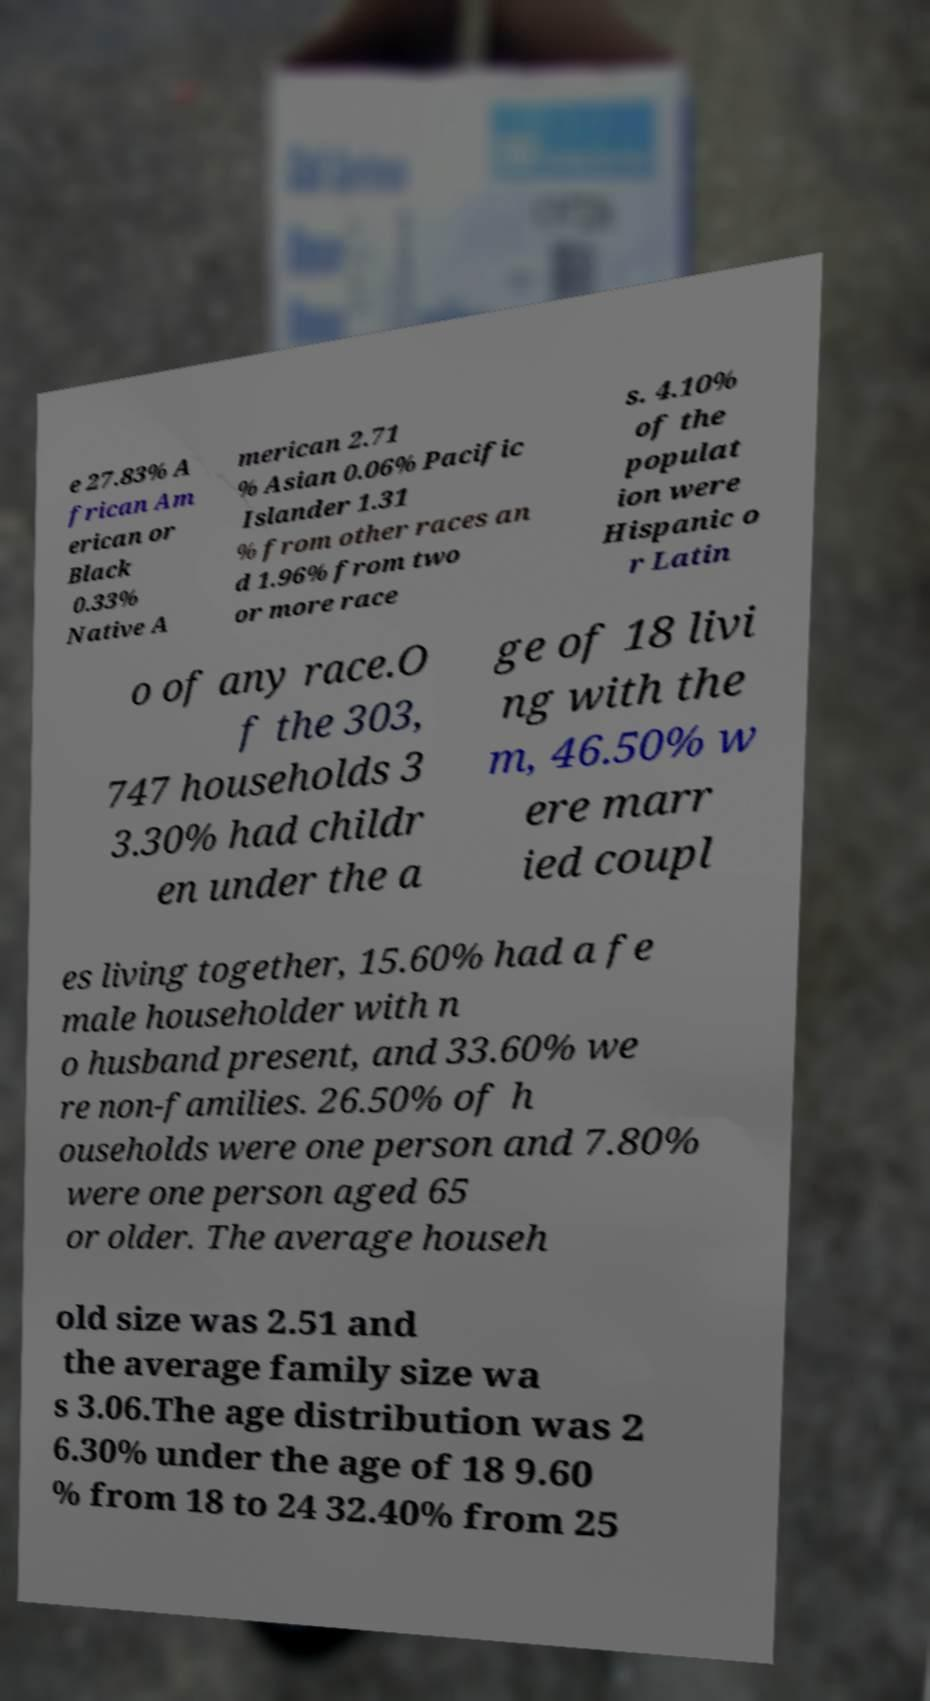There's text embedded in this image that I need extracted. Can you transcribe it verbatim? e 27.83% A frican Am erican or Black 0.33% Native A merican 2.71 % Asian 0.06% Pacific Islander 1.31 % from other races an d 1.96% from two or more race s. 4.10% of the populat ion were Hispanic o r Latin o of any race.O f the 303, 747 households 3 3.30% had childr en under the a ge of 18 livi ng with the m, 46.50% w ere marr ied coupl es living together, 15.60% had a fe male householder with n o husband present, and 33.60% we re non-families. 26.50% of h ouseholds were one person and 7.80% were one person aged 65 or older. The average househ old size was 2.51 and the average family size wa s 3.06.The age distribution was 2 6.30% under the age of 18 9.60 % from 18 to 24 32.40% from 25 